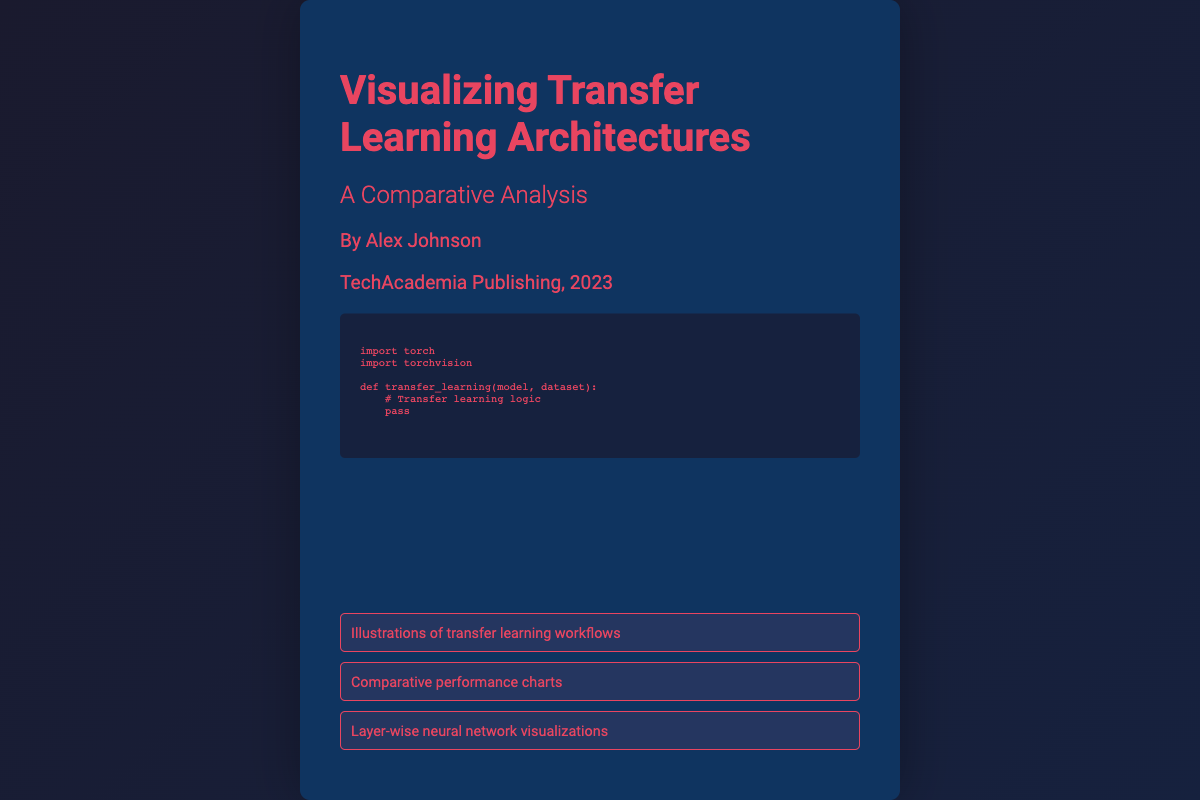What is the title of the book? The title of the book is prominently displayed on the cover, which is "Visualizing Transfer Learning Architectures".
Answer: Visualizing Transfer Learning Architectures Who is the author of the book? The author's name is included in the author section of the cover, which states "By Alex Johnson".
Answer: Alex Johnson What is the name of the publisher? The publisher is mentioned on the cover, stating "TechAcademia Publishing".
Answer: TechAcademia Publishing In what year was the book published? The year of publication is included in the publisher section, which is stated as "2023".
Answer: 2023 What type of illustrations are mentioned on the cover? The visual elements section lists "Illustrations of transfer learning workflows".
Answer: Illustrations of transfer learning workflows What is one of the visual elements included in the book? The visual elements section mentions "Comparative performance charts", indicating a type of visualization present in the book.
Answer: Comparative performance charts What does the code snippet pertain to? The code snippet is indicative of "transfer learning logic" as seen in the comment above the code.
Answer: Transfer learning logic What font style is used for the code snippet? The code snippet uses the "Source Code Pro" font style as indicated in the CSS styling.
Answer: Source Code Pro How many visual elements are shown on the book cover? There are three visual elements listed in the visual elements section of the cover.
Answer: Three 